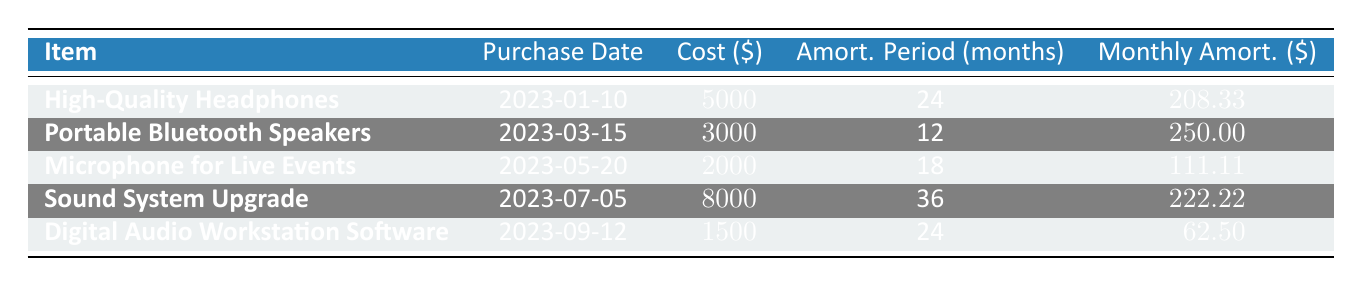What is the cost of the Portable Bluetooth Speakers? The table lists the "Cost ($)" for each item. For the Portable Bluetooth Speakers, the value provided is 3000.
Answer: 3000 What item has the highest monthly amortization? By comparing the "Monthly Amort. ($)" values, the Sound System Upgrade has the highest value at 222.22.
Answer: Sound System Upgrade How long is the amortization period for the High-Quality Headphones? The "Amort. Period (months)" column shows that the High-Quality Headphones have an amortization period of 24 months.
Answer: 24 Is the Digital Audio Workstation Software amortized over more than 20 months? The table indicates that the amortization period for the Digital Audio Workstation Software is 24 months, which is greater than 20 months.
Answer: Yes What is the total monthly amortization for all items listed in the table? The total monthly amortization is calculated by adding all monthly amortizations together: 208.33 + 250 + 111.11 + 222.22 + 62.50 = 854.16.
Answer: 854.16 Which item was purchased most recently? From the "Purchase Date" column, the Digital Audio Workstation Software was purchased on 2023-09-12, making it the most recent purchase.
Answer: Digital Audio Workstation Software If we average the monthly amortizations for all items, what is the result? To find the average, sum the monthly amortizations: 208.33 + 250 + 111.11 + 222.22 + 62.50 = 854.16, then divide by the number of items (5), giving 854.16 / 5 = 170.83.
Answer: 170.83 Does the Microphone for Live Events have a shorter amortization period than the Portable Bluetooth Speakers? The Microphone for Live Events has an amortization period of 18 months, while the Portable Bluetooth Speakers have 12 months, making the statement false.
Answer: No What is the total cost of all items rounded to the nearest hundred? Adding the costs: 5000 + 3000 + 2000 + 8000 + 1500 = 19500. Rounding to the nearest hundred gives 19500.
Answer: 19500 